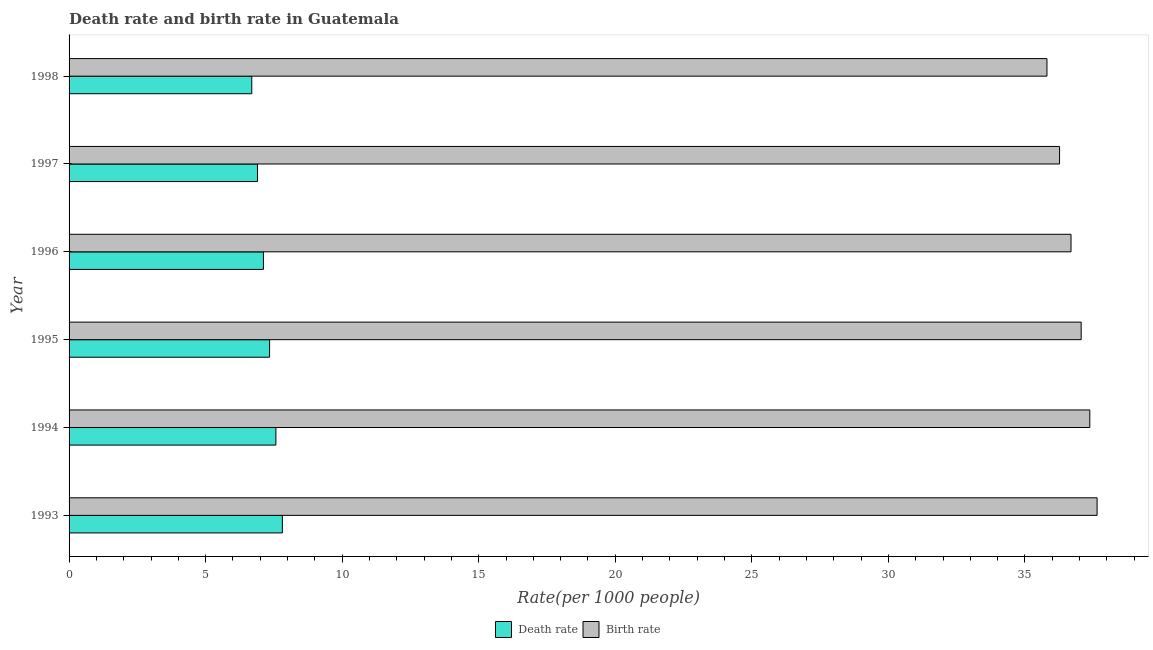How many different coloured bars are there?
Your response must be concise. 2. How many groups of bars are there?
Your answer should be very brief. 6. Are the number of bars per tick equal to the number of legend labels?
Keep it short and to the point. Yes. Are the number of bars on each tick of the Y-axis equal?
Keep it short and to the point. Yes. How many bars are there on the 4th tick from the bottom?
Give a very brief answer. 2. What is the label of the 5th group of bars from the top?
Ensure brevity in your answer.  1994. In how many cases, is the number of bars for a given year not equal to the number of legend labels?
Offer a terse response. 0. What is the death rate in 1995?
Your answer should be very brief. 7.34. Across all years, what is the maximum birth rate?
Provide a short and direct response. 37.64. Across all years, what is the minimum death rate?
Provide a succinct answer. 6.69. In which year was the birth rate maximum?
Your response must be concise. 1993. In which year was the death rate minimum?
Offer a very short reply. 1998. What is the total death rate in the graph?
Your answer should be compact. 43.43. What is the difference between the birth rate in 1996 and that in 1997?
Make the answer very short. 0.42. What is the difference between the birth rate in 1998 and the death rate in 1997?
Give a very brief answer. 28.91. What is the average birth rate per year?
Your answer should be very brief. 36.81. In the year 1995, what is the difference between the death rate and birth rate?
Your response must be concise. -29.72. In how many years, is the birth rate greater than 29 ?
Offer a very short reply. 6. What is the ratio of the death rate in 1996 to that in 1998?
Ensure brevity in your answer.  1.06. Is the difference between the birth rate in 1995 and 1996 greater than the difference between the death rate in 1995 and 1996?
Give a very brief answer. Yes. What is the difference between the highest and the second highest birth rate?
Offer a terse response. 0.27. What is the difference between the highest and the lowest birth rate?
Offer a terse response. 1.84. What does the 2nd bar from the top in 1996 represents?
Offer a very short reply. Death rate. What does the 2nd bar from the bottom in 1994 represents?
Offer a terse response. Birth rate. How many bars are there?
Make the answer very short. 12. How many years are there in the graph?
Keep it short and to the point. 6. Where does the legend appear in the graph?
Provide a short and direct response. Bottom center. What is the title of the graph?
Offer a terse response. Death rate and birth rate in Guatemala. Does "Goods" appear as one of the legend labels in the graph?
Offer a terse response. No. What is the label or title of the X-axis?
Your answer should be compact. Rate(per 1000 people). What is the Rate(per 1000 people) in Death rate in 1993?
Your answer should be compact. 7.81. What is the Rate(per 1000 people) of Birth rate in 1993?
Give a very brief answer. 37.64. What is the Rate(per 1000 people) of Death rate in 1994?
Provide a succinct answer. 7.57. What is the Rate(per 1000 people) in Birth rate in 1994?
Your response must be concise. 37.38. What is the Rate(per 1000 people) of Death rate in 1995?
Provide a short and direct response. 7.34. What is the Rate(per 1000 people) in Birth rate in 1995?
Ensure brevity in your answer.  37.06. What is the Rate(per 1000 people) of Death rate in 1996?
Offer a terse response. 7.12. What is the Rate(per 1000 people) in Birth rate in 1996?
Make the answer very short. 36.69. What is the Rate(per 1000 people) of Death rate in 1997?
Provide a short and direct response. 6.9. What is the Rate(per 1000 people) of Birth rate in 1997?
Make the answer very short. 36.27. What is the Rate(per 1000 people) of Death rate in 1998?
Make the answer very short. 6.69. What is the Rate(per 1000 people) in Birth rate in 1998?
Ensure brevity in your answer.  35.81. Across all years, what is the maximum Rate(per 1000 people) of Death rate?
Provide a short and direct response. 7.81. Across all years, what is the maximum Rate(per 1000 people) in Birth rate?
Your response must be concise. 37.64. Across all years, what is the minimum Rate(per 1000 people) in Death rate?
Your answer should be compact. 6.69. Across all years, what is the minimum Rate(per 1000 people) in Birth rate?
Your response must be concise. 35.81. What is the total Rate(per 1000 people) of Death rate in the graph?
Make the answer very short. 43.43. What is the total Rate(per 1000 people) in Birth rate in the graph?
Ensure brevity in your answer.  220.84. What is the difference between the Rate(per 1000 people) in Death rate in 1993 and that in 1994?
Offer a terse response. 0.24. What is the difference between the Rate(per 1000 people) of Birth rate in 1993 and that in 1994?
Your response must be concise. 0.27. What is the difference between the Rate(per 1000 people) of Death rate in 1993 and that in 1995?
Make the answer very short. 0.47. What is the difference between the Rate(per 1000 people) in Birth rate in 1993 and that in 1995?
Your response must be concise. 0.58. What is the difference between the Rate(per 1000 people) of Death rate in 1993 and that in 1996?
Ensure brevity in your answer.  0.69. What is the difference between the Rate(per 1000 people) in Birth rate in 1993 and that in 1996?
Your answer should be very brief. 0.95. What is the difference between the Rate(per 1000 people) of Death rate in 1993 and that in 1997?
Make the answer very short. 0.91. What is the difference between the Rate(per 1000 people) in Birth rate in 1993 and that in 1997?
Make the answer very short. 1.37. What is the difference between the Rate(per 1000 people) of Death rate in 1993 and that in 1998?
Ensure brevity in your answer.  1.12. What is the difference between the Rate(per 1000 people) of Birth rate in 1993 and that in 1998?
Your response must be concise. 1.84. What is the difference between the Rate(per 1000 people) of Death rate in 1994 and that in 1995?
Offer a terse response. 0.23. What is the difference between the Rate(per 1000 people) in Birth rate in 1994 and that in 1995?
Make the answer very short. 0.32. What is the difference between the Rate(per 1000 people) in Death rate in 1994 and that in 1996?
Provide a short and direct response. 0.46. What is the difference between the Rate(per 1000 people) in Birth rate in 1994 and that in 1996?
Provide a succinct answer. 0.69. What is the difference between the Rate(per 1000 people) of Death rate in 1994 and that in 1997?
Offer a terse response. 0.67. What is the difference between the Rate(per 1000 people) of Birth rate in 1994 and that in 1997?
Your answer should be very brief. 1.11. What is the difference between the Rate(per 1000 people) of Death rate in 1994 and that in 1998?
Offer a very short reply. 0.88. What is the difference between the Rate(per 1000 people) in Birth rate in 1994 and that in 1998?
Keep it short and to the point. 1.57. What is the difference between the Rate(per 1000 people) of Death rate in 1995 and that in 1996?
Your answer should be very brief. 0.23. What is the difference between the Rate(per 1000 people) in Birth rate in 1995 and that in 1996?
Your response must be concise. 0.37. What is the difference between the Rate(per 1000 people) of Death rate in 1995 and that in 1997?
Offer a terse response. 0.44. What is the difference between the Rate(per 1000 people) in Birth rate in 1995 and that in 1997?
Make the answer very short. 0.79. What is the difference between the Rate(per 1000 people) in Death rate in 1995 and that in 1998?
Your answer should be compact. 0.65. What is the difference between the Rate(per 1000 people) of Birth rate in 1995 and that in 1998?
Offer a terse response. 1.25. What is the difference between the Rate(per 1000 people) of Death rate in 1996 and that in 1997?
Keep it short and to the point. 0.22. What is the difference between the Rate(per 1000 people) in Birth rate in 1996 and that in 1997?
Your response must be concise. 0.42. What is the difference between the Rate(per 1000 people) of Death rate in 1996 and that in 1998?
Offer a very short reply. 0.43. What is the difference between the Rate(per 1000 people) of Birth rate in 1996 and that in 1998?
Ensure brevity in your answer.  0.88. What is the difference between the Rate(per 1000 people) of Death rate in 1997 and that in 1998?
Your answer should be compact. 0.21. What is the difference between the Rate(per 1000 people) in Birth rate in 1997 and that in 1998?
Offer a terse response. 0.46. What is the difference between the Rate(per 1000 people) of Death rate in 1993 and the Rate(per 1000 people) of Birth rate in 1994?
Your answer should be compact. -29.57. What is the difference between the Rate(per 1000 people) of Death rate in 1993 and the Rate(per 1000 people) of Birth rate in 1995?
Make the answer very short. -29.25. What is the difference between the Rate(per 1000 people) in Death rate in 1993 and the Rate(per 1000 people) in Birth rate in 1996?
Ensure brevity in your answer.  -28.88. What is the difference between the Rate(per 1000 people) of Death rate in 1993 and the Rate(per 1000 people) of Birth rate in 1997?
Provide a succinct answer. -28.46. What is the difference between the Rate(per 1000 people) in Death rate in 1993 and the Rate(per 1000 people) in Birth rate in 1998?
Ensure brevity in your answer.  -28. What is the difference between the Rate(per 1000 people) in Death rate in 1994 and the Rate(per 1000 people) in Birth rate in 1995?
Offer a terse response. -29.49. What is the difference between the Rate(per 1000 people) of Death rate in 1994 and the Rate(per 1000 people) of Birth rate in 1996?
Offer a terse response. -29.11. What is the difference between the Rate(per 1000 people) in Death rate in 1994 and the Rate(per 1000 people) in Birth rate in 1997?
Your answer should be very brief. -28.7. What is the difference between the Rate(per 1000 people) in Death rate in 1994 and the Rate(per 1000 people) in Birth rate in 1998?
Give a very brief answer. -28.23. What is the difference between the Rate(per 1000 people) of Death rate in 1995 and the Rate(per 1000 people) of Birth rate in 1996?
Your answer should be compact. -29.34. What is the difference between the Rate(per 1000 people) of Death rate in 1995 and the Rate(per 1000 people) of Birth rate in 1997?
Your answer should be compact. -28.93. What is the difference between the Rate(per 1000 people) of Death rate in 1995 and the Rate(per 1000 people) of Birth rate in 1998?
Your answer should be very brief. -28.46. What is the difference between the Rate(per 1000 people) in Death rate in 1996 and the Rate(per 1000 people) in Birth rate in 1997?
Keep it short and to the point. -29.15. What is the difference between the Rate(per 1000 people) of Death rate in 1996 and the Rate(per 1000 people) of Birth rate in 1998?
Offer a very short reply. -28.69. What is the difference between the Rate(per 1000 people) in Death rate in 1997 and the Rate(per 1000 people) in Birth rate in 1998?
Offer a very short reply. -28.91. What is the average Rate(per 1000 people) of Death rate per year?
Ensure brevity in your answer.  7.24. What is the average Rate(per 1000 people) of Birth rate per year?
Offer a terse response. 36.81. In the year 1993, what is the difference between the Rate(per 1000 people) in Death rate and Rate(per 1000 people) in Birth rate?
Offer a terse response. -29.83. In the year 1994, what is the difference between the Rate(per 1000 people) in Death rate and Rate(per 1000 people) in Birth rate?
Make the answer very short. -29.8. In the year 1995, what is the difference between the Rate(per 1000 people) of Death rate and Rate(per 1000 people) of Birth rate?
Provide a short and direct response. -29.72. In the year 1996, what is the difference between the Rate(per 1000 people) in Death rate and Rate(per 1000 people) in Birth rate?
Your answer should be compact. -29.57. In the year 1997, what is the difference between the Rate(per 1000 people) of Death rate and Rate(per 1000 people) of Birth rate?
Give a very brief answer. -29.37. In the year 1998, what is the difference between the Rate(per 1000 people) in Death rate and Rate(per 1000 people) in Birth rate?
Your response must be concise. -29.12. What is the ratio of the Rate(per 1000 people) in Death rate in 1993 to that in 1994?
Offer a terse response. 1.03. What is the ratio of the Rate(per 1000 people) of Birth rate in 1993 to that in 1994?
Your answer should be compact. 1.01. What is the ratio of the Rate(per 1000 people) of Death rate in 1993 to that in 1995?
Your response must be concise. 1.06. What is the ratio of the Rate(per 1000 people) of Birth rate in 1993 to that in 1995?
Give a very brief answer. 1.02. What is the ratio of the Rate(per 1000 people) of Death rate in 1993 to that in 1996?
Your response must be concise. 1.1. What is the ratio of the Rate(per 1000 people) of Death rate in 1993 to that in 1997?
Your response must be concise. 1.13. What is the ratio of the Rate(per 1000 people) of Birth rate in 1993 to that in 1997?
Make the answer very short. 1.04. What is the ratio of the Rate(per 1000 people) in Death rate in 1993 to that in 1998?
Make the answer very short. 1.17. What is the ratio of the Rate(per 1000 people) of Birth rate in 1993 to that in 1998?
Make the answer very short. 1.05. What is the ratio of the Rate(per 1000 people) of Death rate in 1994 to that in 1995?
Provide a succinct answer. 1.03. What is the ratio of the Rate(per 1000 people) in Birth rate in 1994 to that in 1995?
Your response must be concise. 1.01. What is the ratio of the Rate(per 1000 people) of Death rate in 1994 to that in 1996?
Offer a very short reply. 1.06. What is the ratio of the Rate(per 1000 people) of Birth rate in 1994 to that in 1996?
Provide a short and direct response. 1.02. What is the ratio of the Rate(per 1000 people) of Death rate in 1994 to that in 1997?
Offer a terse response. 1.1. What is the ratio of the Rate(per 1000 people) of Birth rate in 1994 to that in 1997?
Keep it short and to the point. 1.03. What is the ratio of the Rate(per 1000 people) of Death rate in 1994 to that in 1998?
Provide a short and direct response. 1.13. What is the ratio of the Rate(per 1000 people) in Birth rate in 1994 to that in 1998?
Give a very brief answer. 1.04. What is the ratio of the Rate(per 1000 people) of Death rate in 1995 to that in 1996?
Offer a terse response. 1.03. What is the ratio of the Rate(per 1000 people) of Birth rate in 1995 to that in 1996?
Your response must be concise. 1.01. What is the ratio of the Rate(per 1000 people) in Death rate in 1995 to that in 1997?
Your answer should be very brief. 1.06. What is the ratio of the Rate(per 1000 people) in Birth rate in 1995 to that in 1997?
Provide a short and direct response. 1.02. What is the ratio of the Rate(per 1000 people) of Death rate in 1995 to that in 1998?
Your response must be concise. 1.1. What is the ratio of the Rate(per 1000 people) in Birth rate in 1995 to that in 1998?
Offer a terse response. 1.03. What is the ratio of the Rate(per 1000 people) of Death rate in 1996 to that in 1997?
Provide a succinct answer. 1.03. What is the ratio of the Rate(per 1000 people) of Birth rate in 1996 to that in 1997?
Provide a succinct answer. 1.01. What is the ratio of the Rate(per 1000 people) in Death rate in 1996 to that in 1998?
Keep it short and to the point. 1.06. What is the ratio of the Rate(per 1000 people) of Birth rate in 1996 to that in 1998?
Make the answer very short. 1.02. What is the ratio of the Rate(per 1000 people) in Death rate in 1997 to that in 1998?
Offer a very short reply. 1.03. What is the ratio of the Rate(per 1000 people) of Birth rate in 1997 to that in 1998?
Provide a succinct answer. 1.01. What is the difference between the highest and the second highest Rate(per 1000 people) in Death rate?
Your response must be concise. 0.24. What is the difference between the highest and the second highest Rate(per 1000 people) of Birth rate?
Make the answer very short. 0.27. What is the difference between the highest and the lowest Rate(per 1000 people) in Death rate?
Your answer should be very brief. 1.12. What is the difference between the highest and the lowest Rate(per 1000 people) in Birth rate?
Provide a succinct answer. 1.84. 